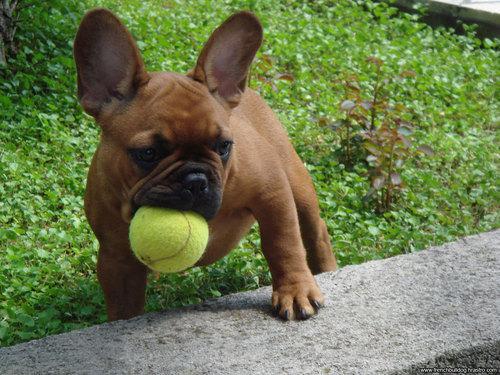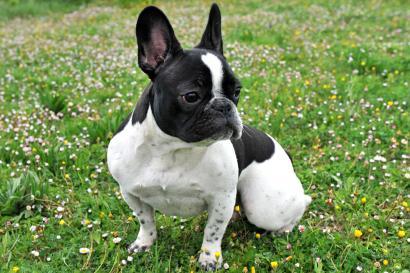The first image is the image on the left, the second image is the image on the right. For the images displayed, is the sentence "One image shows a black and white dog on a field scattered with wild flowers." factually correct? Answer yes or no. Yes. 